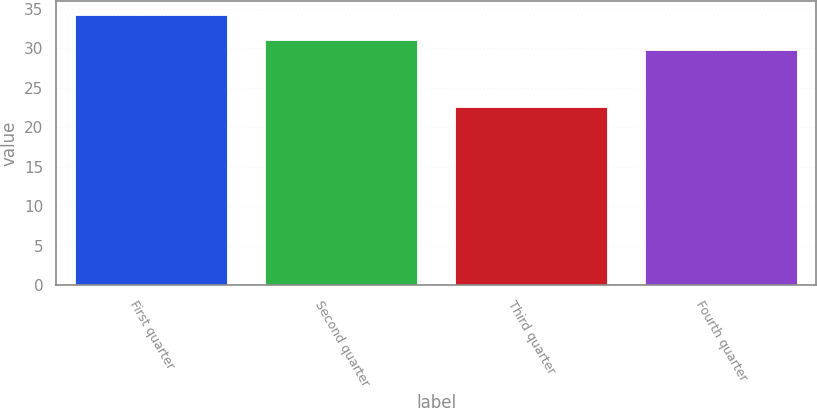Convert chart. <chart><loc_0><loc_0><loc_500><loc_500><bar_chart><fcel>First quarter<fcel>Second quarter<fcel>Third quarter<fcel>Fourth quarter<nl><fcel>34.25<fcel>31.06<fcel>22.63<fcel>29.85<nl></chart> 